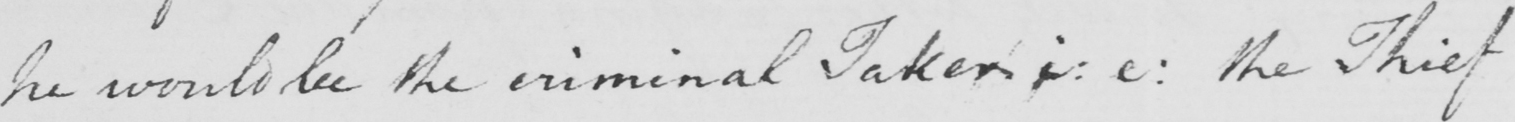Can you tell me what this handwritten text says? he would be the criminal Taken i : e :  the Thief 